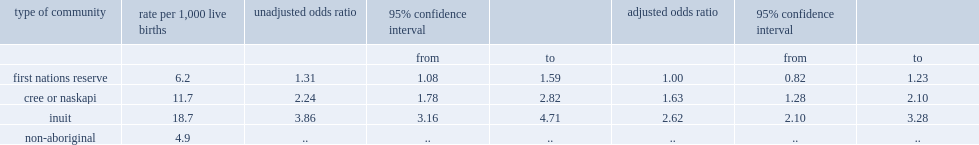Was infant mortality higher for aboriginal people living on first nations reserves or was that for non-aboriginal people? First nations reserve. Was infant mortality higher for aboriginal people living in cree and naskapi communities or was that for non-aboriginal people? Cree or naskapi. Was infant mortality higher for aboriginal people living in inuit communities or was that for non-aboriginal people? Inuit. 